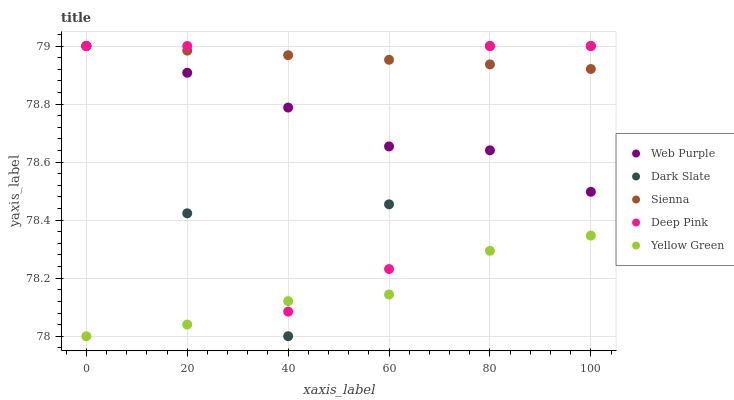Does Yellow Green have the minimum area under the curve?
Answer yes or no. Yes. Does Sienna have the maximum area under the curve?
Answer yes or no. Yes. Does Dark Slate have the minimum area under the curve?
Answer yes or no. No. Does Dark Slate have the maximum area under the curve?
Answer yes or no. No. Is Sienna the smoothest?
Answer yes or no. Yes. Is Deep Pink the roughest?
Answer yes or no. Yes. Is Dark Slate the smoothest?
Answer yes or no. No. Is Dark Slate the roughest?
Answer yes or no. No. Does Yellow Green have the lowest value?
Answer yes or no. Yes. Does Dark Slate have the lowest value?
Answer yes or no. No. Does Deep Pink have the highest value?
Answer yes or no. Yes. Does Yellow Green have the highest value?
Answer yes or no. No. Is Yellow Green less than Web Purple?
Answer yes or no. Yes. Is Web Purple greater than Yellow Green?
Answer yes or no. Yes. Does Web Purple intersect Dark Slate?
Answer yes or no. Yes. Is Web Purple less than Dark Slate?
Answer yes or no. No. Is Web Purple greater than Dark Slate?
Answer yes or no. No. Does Yellow Green intersect Web Purple?
Answer yes or no. No. 